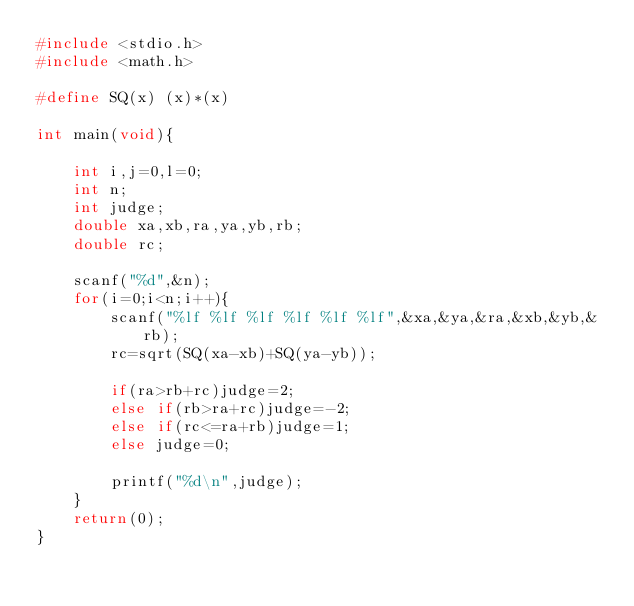<code> <loc_0><loc_0><loc_500><loc_500><_C_>#include <stdio.h>
#include <math.h>

#define SQ(x) (x)*(x)

int main(void){
    
    int i,j=0,l=0;
    int n;
    int judge;
    double xa,xb,ra,ya,yb,rb;
    double rc;
    
    scanf("%d",&n);
    for(i=0;i<n;i++){
        scanf("%lf %lf %lf %lf %lf %lf",&xa,&ya,&ra,&xb,&yb,&rb);
        rc=sqrt(SQ(xa-xb)+SQ(ya-yb));
        
        if(ra>rb+rc)judge=2;
        else if(rb>ra+rc)judge=-2;
        else if(rc<=ra+rb)judge=1;
        else judge=0;
        
        printf("%d\n",judge);
    }
    return(0);
}</code> 